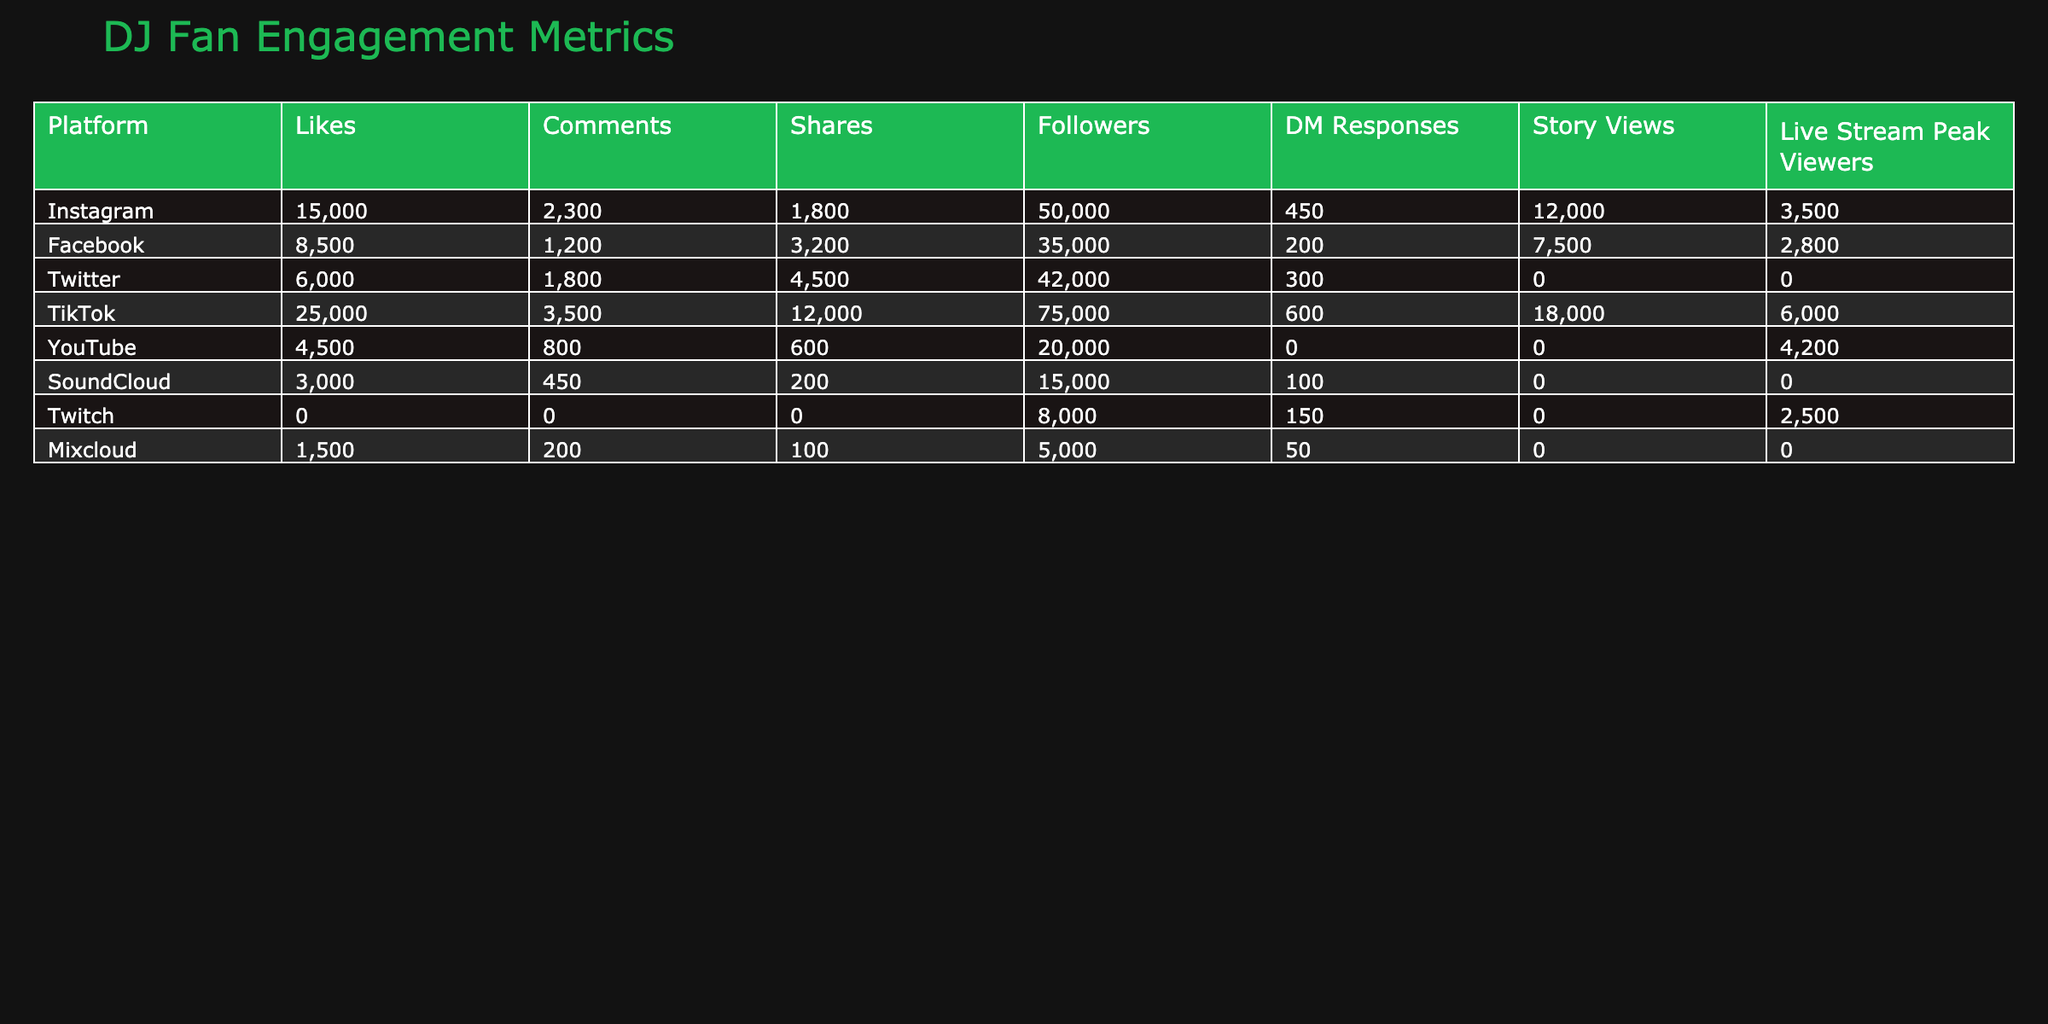What platform has the highest number of likes? By scanning the "Likes" column, Instagram has 15,000 likes, which is higher than the likes of Facebook, Twitter, TikTok, YouTube, SoundCloud, Twitch, and Mixcloud.
Answer: Instagram What is the total number of comments across all platforms? Adding the comments from each platform: 2300 (Instagram) + 1200 (Facebook) + 1800 (Twitter) + 3500 (TikTok) + 800 (YouTube) + 450 (SoundCloud) + 200 (Mixcloud) = 10,250.
Answer: 10,250 Does TikTok have the most shares of any platform? TikTok has 12,000 shares, which is more than Instagram (1800), Facebook (3200), Twitter (4500), YouTube (600), SoundCloud (200), and Mixcloud (100). Therefore, it is true that TikTok has the most shares.
Answer: Yes What is the average number of followers across all platforms listed? To find the average, we first sum the followers of each platform (50000 + 35000 + 42000 + 75000 + 20000 + 15000 + 8000 + 5000) which totals 257,000. Since there are 8 platforms, the average is 257,000 / 8 = 32,125.
Answer: 32,125 Which platform has the highest DM responses? Checking the "DM Responses" column, TikTok has the highest at 600 responses, which is greater than others like Instagram (450), Facebook (200), and SoundCloud (100).
Answer: TikTok What percentage of total story views does Instagram account for? First, we sum the story views: 12000 (Instagram) + 7500 (Facebook) + 18000 (TikTok) + N/A (YouTube) + N/A (SoundCloud) + N/A (Twitch) + N/A (Mixcloud). The total is 42,500. The percentage for Instagram is (12000 / 42500) * 100 ≈ 28.24%.
Answer: 28.24% If we consider platforms with available live stream peak viewers, what is the total for Instagram and TikTok? The live stream peak viewers for Instagram is 3500 and for TikTok is 6000. Adding these gives us 3500 + 6000 = 9500.
Answer: 9500 Which platform is missing data for likes, comments, and shares? By reviewing the table, Twitch shows 'N/A' for likes, comments, and shares, indicating that no data is available for these metrics.
Answer: Twitch What is the difference in average followers between the platform with the highest followers and that with the lowest? The highest followers are on TikTok with 75,000, and the lowest is Mixcloud with 5,000. The difference is 75,000 - 5,000 = 70,000.
Answer: 70,000 Which platform has the least engagement based on total likes, comments, and shares? If we sum the engagement metrics (likes, comments, shares) for each platform, SoundCloud has 3,200 (3000 likes + 450 comments + 200 shares), which is lower than all others.
Answer: SoundCloud 